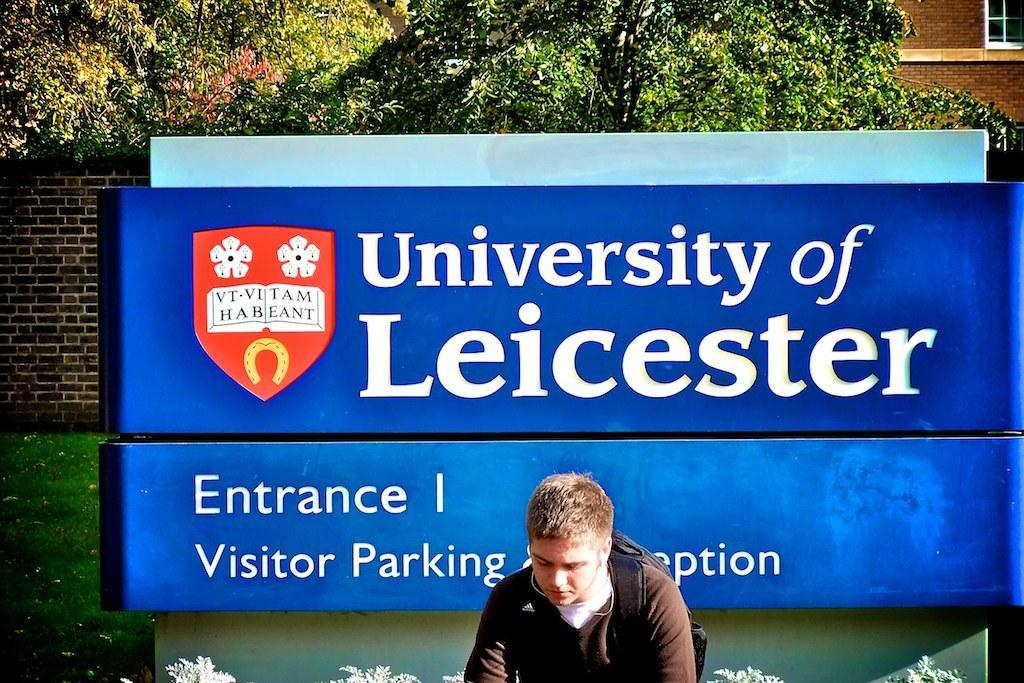<image>
Relay a brief, clear account of the picture shown. An entrance I sign for the University of Leicester 